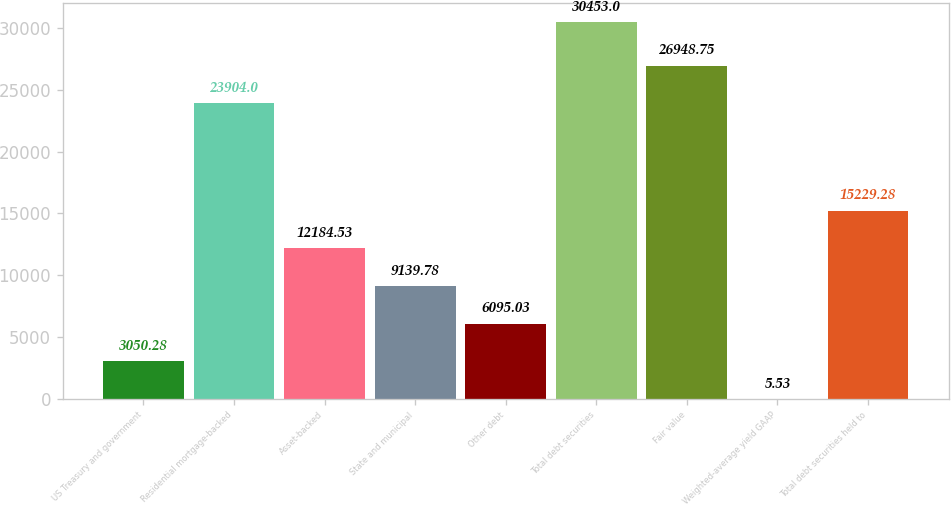<chart> <loc_0><loc_0><loc_500><loc_500><bar_chart><fcel>US Treasury and government<fcel>Residential mortgage-backed<fcel>Asset-backed<fcel>State and municipal<fcel>Other debt<fcel>Total debt securities<fcel>Fair value<fcel>Weighted-average yield GAAP<fcel>Total debt securities held to<nl><fcel>3050.28<fcel>23904<fcel>12184.5<fcel>9139.78<fcel>6095.03<fcel>30453<fcel>26948.8<fcel>5.53<fcel>15229.3<nl></chart> 